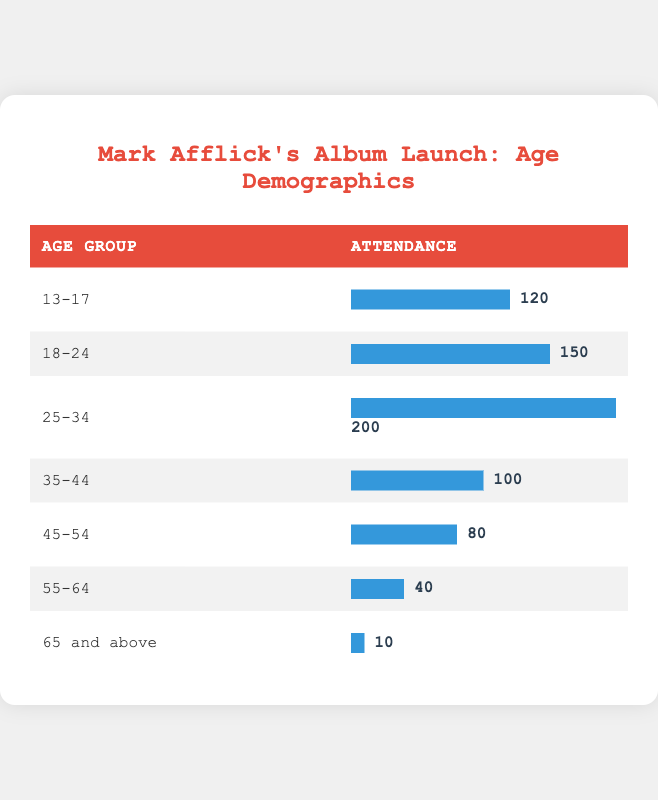What is the age group with the highest attendance? The table shows the attendance for each age group. Looking at the numbers, the age group "25-34" has the highest attendance with 200 attendees.
Answer: 25-34 How many attendees were there in the age group 18-24? The table clearly states the attendance for the age group "18-24" is 150.
Answer: 150 What is the total attendance for all age groups combined? To find the total attendance, we need to sum the attendance of all age groups: 120 + 150 + 200 + 100 + 80 + 40 + 10 = 700.
Answer: 700 Is there more attendance from the age group 35-44 compared to 45-54? The attendance for "35-44" is 100, while for "45-54" it is 80. Since 100 is greater than 80, the statement is true.
Answer: Yes What percentage of attendees are aged 65 and above? The total attendance is 700. The attendance for "65 and above" is 10. To find the percentage: (10 / 700) * 100 = 1.43%.
Answer: 1.43% Which age group has the least attendance? The table lists the attendance, and the age group "65 and above" has the least attendance, with only 10 attendees.
Answer: 65 and above How many more attendees are there in the age group 25-34 than in the age group 55-64? The attendance for "25-34" is 200, and for "55-64" it is 40. The difference is 200 - 40 = 160.
Answer: 160 What is the average attendance across all age groups? To find the average, we sum the attendance (700) and divide by the number of age groups (7): 700 / 7 = 100.
Answer: 100 Are there more attendees in the age groups 13-17 and 18-24 combined than in the age group 45-54? The combined attendance for "13-17" (120) and "18-24" (150) is 270. The attendance for "45-54" is 80. Since 270 is greater than 80, the statement is true.
Answer: Yes 